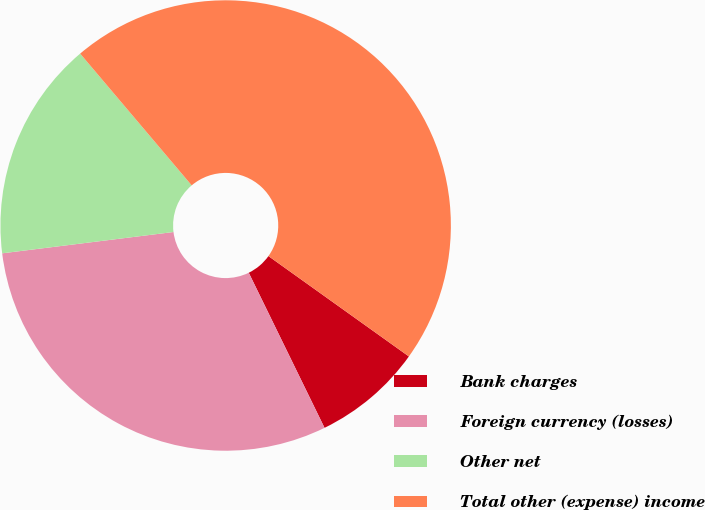Convert chart to OTSL. <chart><loc_0><loc_0><loc_500><loc_500><pie_chart><fcel>Bank charges<fcel>Foreign currency (losses)<fcel>Other net<fcel>Total other (expense) income<nl><fcel>7.89%<fcel>30.26%<fcel>15.79%<fcel>46.05%<nl></chart> 